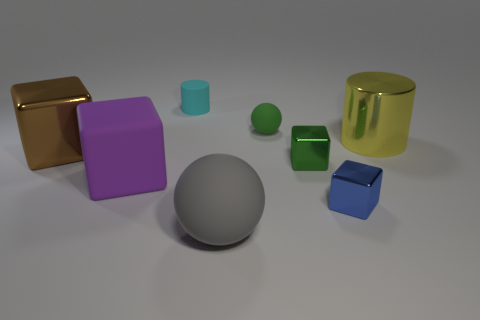Subtract all red cubes. Subtract all red balls. How many cubes are left? 4 Add 1 tiny green rubber blocks. How many objects exist? 9 Subtract all cylinders. How many objects are left? 6 Subtract 0 cyan spheres. How many objects are left? 8 Subtract all small yellow cylinders. Subtract all big yellow things. How many objects are left? 7 Add 5 cylinders. How many cylinders are left? 7 Add 8 big purple metal blocks. How many big purple metal blocks exist? 8 